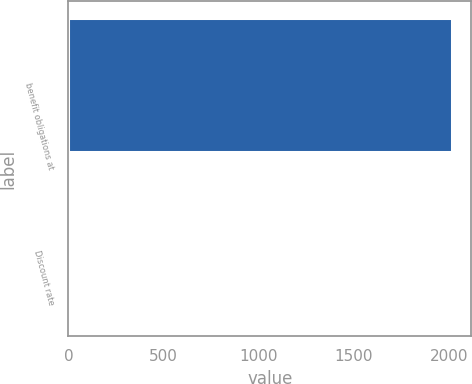Convert chart to OTSL. <chart><loc_0><loc_0><loc_500><loc_500><bar_chart><fcel>benefit obligations at<fcel>Discount rate<nl><fcel>2015<fcel>4.39<nl></chart> 